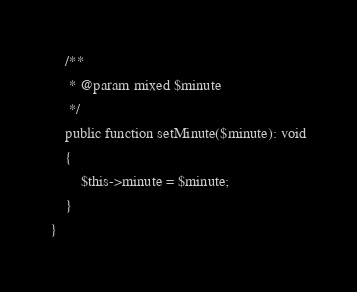Convert code to text. <code><loc_0><loc_0><loc_500><loc_500><_PHP_>    /**
     * @param mixed $minute
     */
    public function setMinute($minute): void
    {
        $this->minute = $minute;
    }
}
</code> 